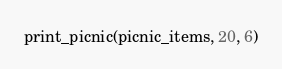Convert code to text. <code><loc_0><loc_0><loc_500><loc_500><_Python_>print_picnic(picnic_items, 20, 6)
</code> 